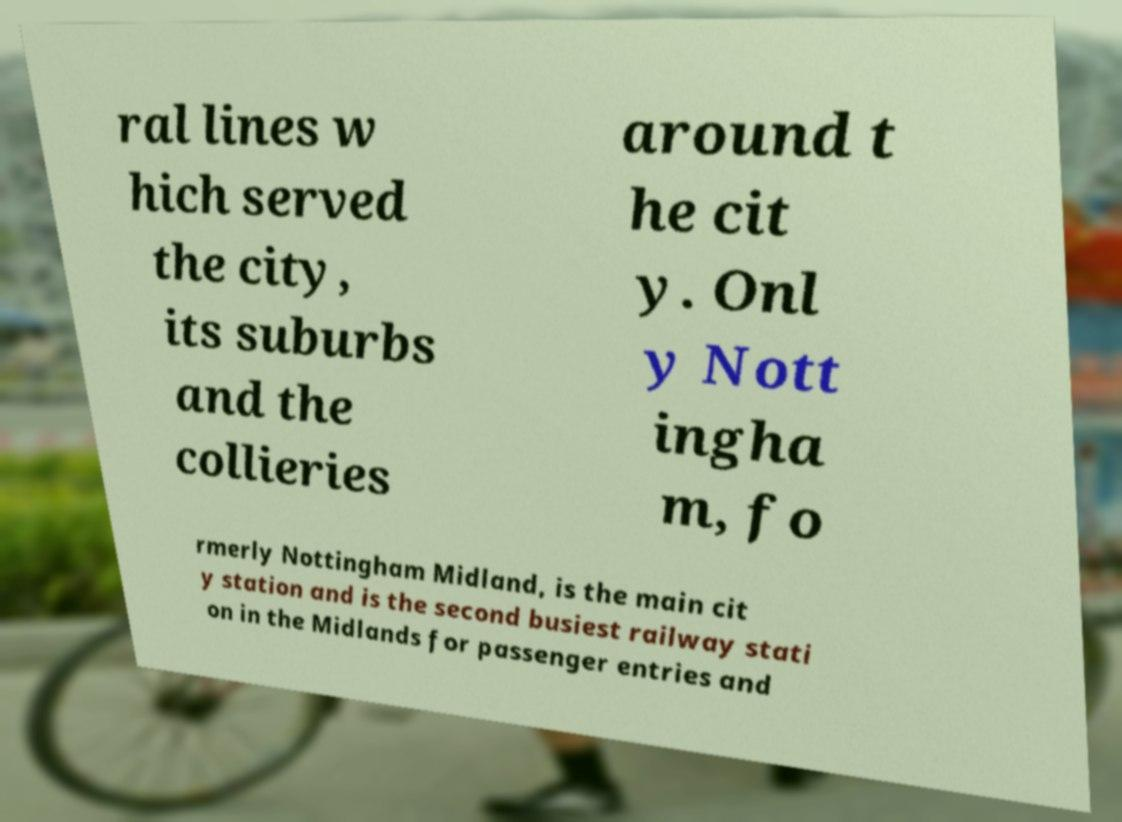What messages or text are displayed in this image? I need them in a readable, typed format. ral lines w hich served the city, its suburbs and the collieries around t he cit y. Onl y Nott ingha m, fo rmerly Nottingham Midland, is the main cit y station and is the second busiest railway stati on in the Midlands for passenger entries and 